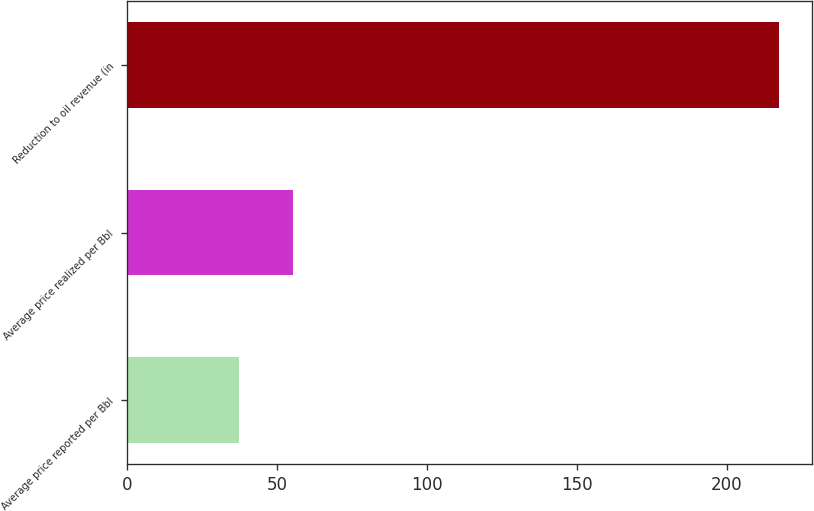<chart> <loc_0><loc_0><loc_500><loc_500><bar_chart><fcel>Average price reported per Bbl<fcel>Average price realized per Bbl<fcel>Reduction to oil revenue (in<nl><fcel>37.22<fcel>55.25<fcel>217.5<nl></chart> 